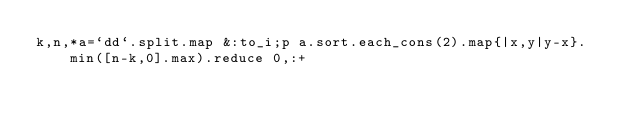Convert code to text. <code><loc_0><loc_0><loc_500><loc_500><_Ruby_>k,n,*a=`dd`.split.map &:to_i;p a.sort.each_cons(2).map{|x,y|y-x}.min([n-k,0].max).reduce 0,:+</code> 